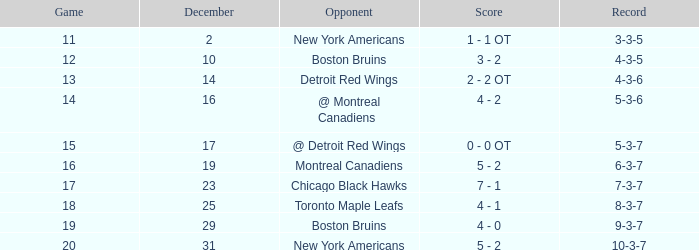Which december possesses a 4-3-6 record? 14.0. 